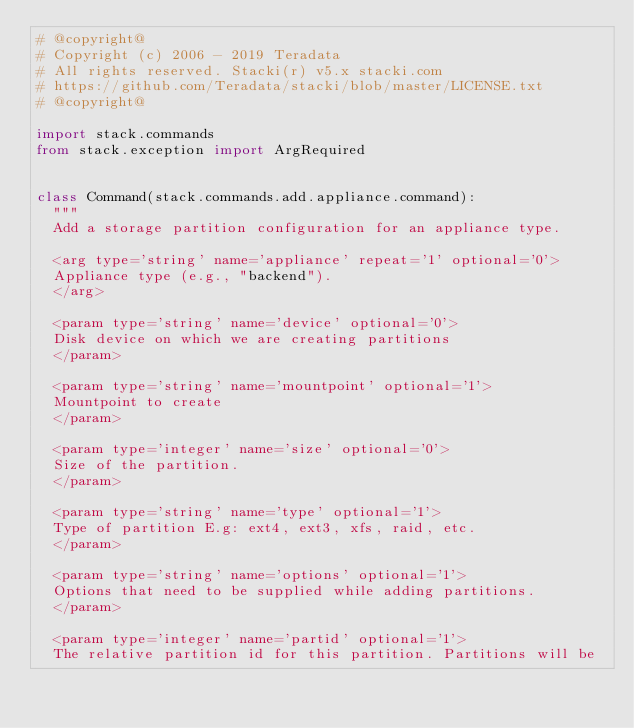Convert code to text. <code><loc_0><loc_0><loc_500><loc_500><_Python_># @copyright@
# Copyright (c) 2006 - 2019 Teradata
# All rights reserved. Stacki(r) v5.x stacki.com
# https://github.com/Teradata/stacki/blob/master/LICENSE.txt
# @copyright@

import stack.commands
from stack.exception import ArgRequired


class Command(stack.commands.add.appliance.command):
	"""
	Add a storage partition configuration for an appliance type.

	<arg type='string' name='appliance' repeat='1' optional='0'>
	Appliance type (e.g., "backend").
	</arg>

	<param type='string' name='device' optional='0'>
	Disk device on which we are creating partitions
	</param>

	<param type='string' name='mountpoint' optional='1'>
	Mountpoint to create
	</param>

	<param type='integer' name='size' optional='0'>
	Size of the partition.
	</param>

	<param type='string' name='type' optional='1'>
	Type of partition E.g: ext4, ext3, xfs, raid, etc.
	</param>

	<param type='string' name='options' optional='1'>
	Options that need to be supplied while adding partitions.
	</param>

	<param type='integer' name='partid' optional='1'>
	The relative partition id for this partition. Partitions will be</code> 